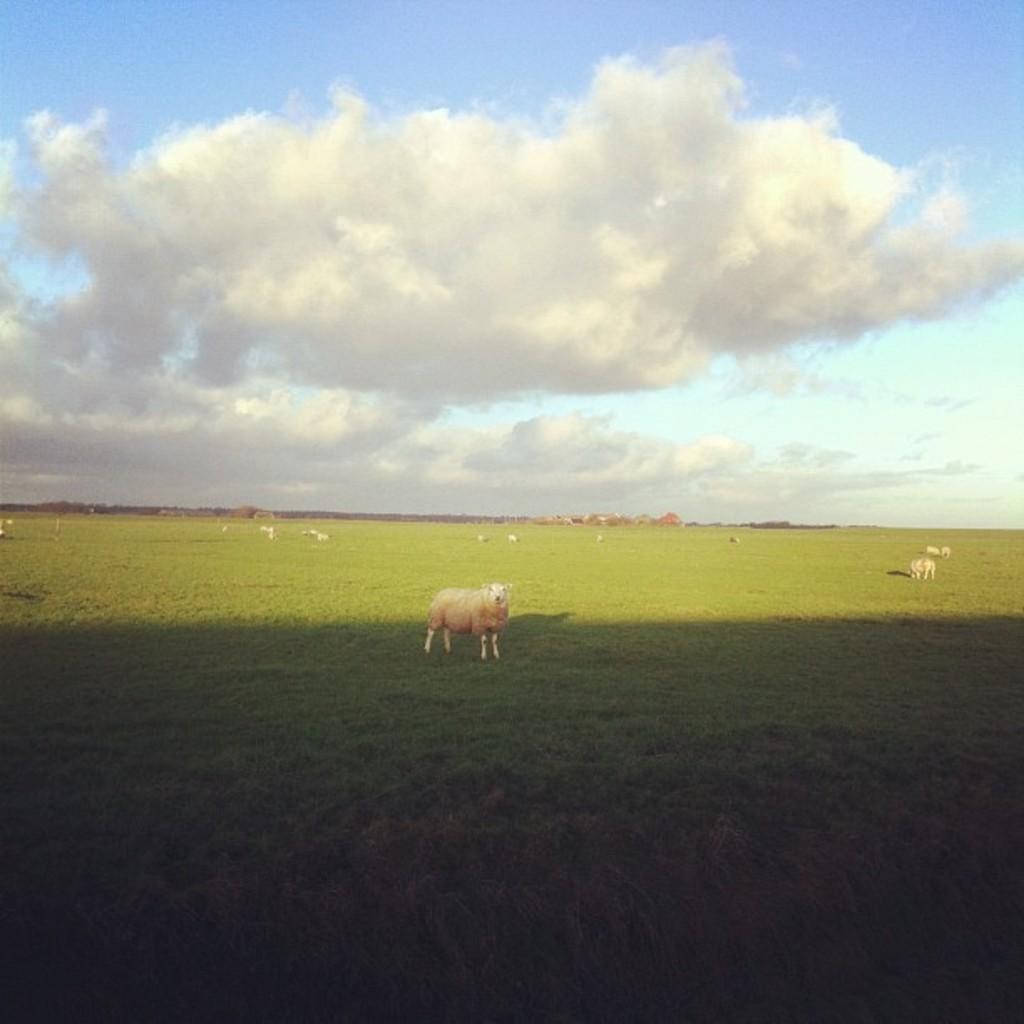Describe this image in one or two sentences. In this picture we can see animals on the ground. Here we can see grass. In the background there is sky with clouds. 